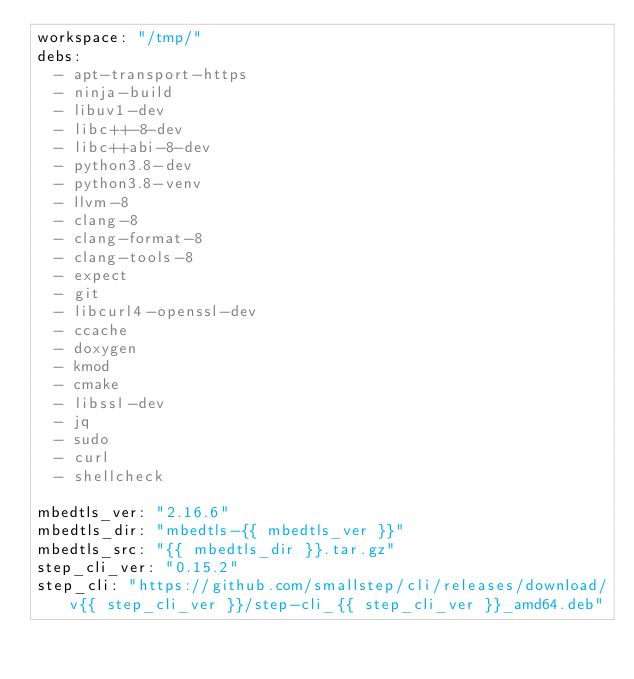<code> <loc_0><loc_0><loc_500><loc_500><_YAML_>workspace: "/tmp/"
debs:
  - apt-transport-https
  - ninja-build
  - libuv1-dev
  - libc++-8-dev
  - libc++abi-8-dev
  - python3.8-dev
  - python3.8-venv
  - llvm-8
  - clang-8
  - clang-format-8
  - clang-tools-8
  - expect
  - git
  - libcurl4-openssl-dev
  - ccache
  - doxygen
  - kmod
  - cmake
  - libssl-dev
  - jq
  - sudo
  - curl
  - shellcheck

mbedtls_ver: "2.16.6"
mbedtls_dir: "mbedtls-{{ mbedtls_ver }}"
mbedtls_src: "{{ mbedtls_dir }}.tar.gz"
step_cli_ver: "0.15.2"
step_cli: "https://github.com/smallstep/cli/releases/download/v{{ step_cli_ver }}/step-cli_{{ step_cli_ver }}_amd64.deb"</code> 